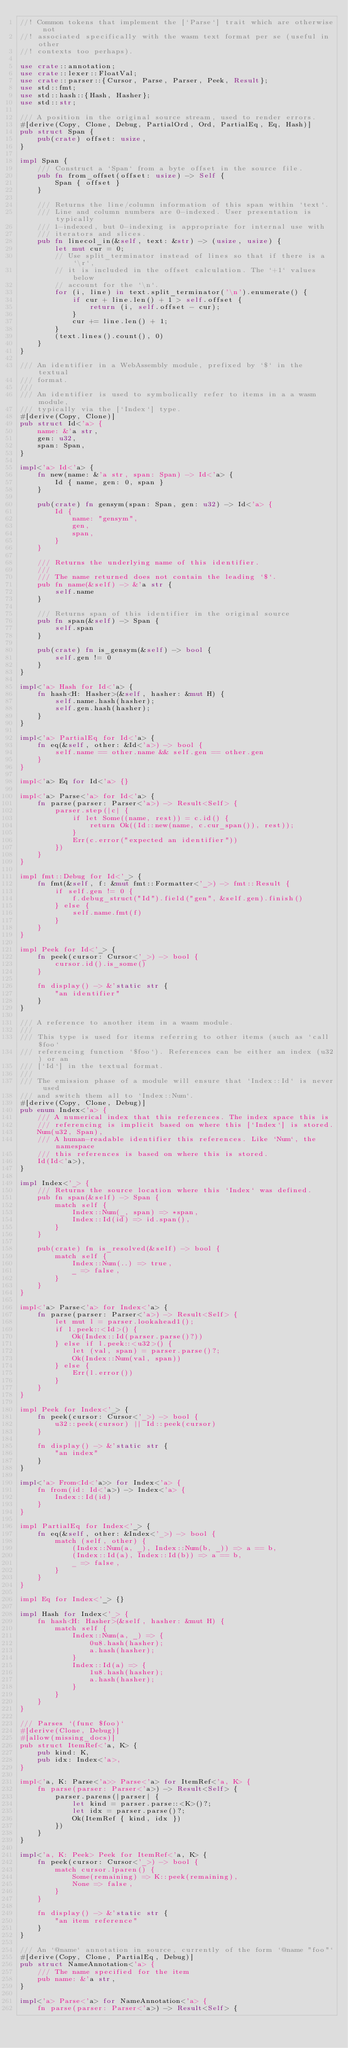<code> <loc_0><loc_0><loc_500><loc_500><_Rust_>//! Common tokens that implement the [`Parse`] trait which are otherwise not
//! associated specifically with the wasm text format per se (useful in other
//! contexts too perhaps).

use crate::annotation;
use crate::lexer::FloatVal;
use crate::parser::{Cursor, Parse, Parser, Peek, Result};
use std::fmt;
use std::hash::{Hash, Hasher};
use std::str;

/// A position in the original source stream, used to render errors.
#[derive(Copy, Clone, Debug, PartialOrd, Ord, PartialEq, Eq, Hash)]
pub struct Span {
    pub(crate) offset: usize,
}

impl Span {
    /// Construct a `Span` from a byte offset in the source file.
    pub fn from_offset(offset: usize) -> Self {
        Span { offset }
    }

    /// Returns the line/column information of this span within `text`.
    /// Line and column numbers are 0-indexed. User presentation is typically
    /// 1-indexed, but 0-indexing is appropriate for internal use with
    /// iterators and slices.
    pub fn linecol_in(&self, text: &str) -> (usize, usize) {
        let mut cur = 0;
        // Use split_terminator instead of lines so that if there is a `\r`,
        // it is included in the offset calculation. The `+1` values below
        // account for the `\n`.
        for (i, line) in text.split_terminator('\n').enumerate() {
            if cur + line.len() + 1 > self.offset {
                return (i, self.offset - cur);
            }
            cur += line.len() + 1;
        }
        (text.lines().count(), 0)
    }
}

/// An identifier in a WebAssembly module, prefixed by `$` in the textual
/// format.
///
/// An identifier is used to symbolically refer to items in a a wasm module,
/// typically via the [`Index`] type.
#[derive(Copy, Clone)]
pub struct Id<'a> {
    name: &'a str,
    gen: u32,
    span: Span,
}

impl<'a> Id<'a> {
    fn new(name: &'a str, span: Span) -> Id<'a> {
        Id { name, gen: 0, span }
    }

    pub(crate) fn gensym(span: Span, gen: u32) -> Id<'a> {
        Id {
            name: "gensym",
            gen,
            span,
        }
    }

    /// Returns the underlying name of this identifier.
    ///
    /// The name returned does not contain the leading `$`.
    pub fn name(&self) -> &'a str {
        self.name
    }

    /// Returns span of this identifier in the original source
    pub fn span(&self) -> Span {
        self.span
    }

    pub(crate) fn is_gensym(&self) -> bool {
        self.gen != 0
    }
}

impl<'a> Hash for Id<'a> {
    fn hash<H: Hasher>(&self, hasher: &mut H) {
        self.name.hash(hasher);
        self.gen.hash(hasher);
    }
}

impl<'a> PartialEq for Id<'a> {
    fn eq(&self, other: &Id<'a>) -> bool {
        self.name == other.name && self.gen == other.gen
    }
}

impl<'a> Eq for Id<'a> {}

impl<'a> Parse<'a> for Id<'a> {
    fn parse(parser: Parser<'a>) -> Result<Self> {
        parser.step(|c| {
            if let Some((name, rest)) = c.id() {
                return Ok((Id::new(name, c.cur_span()), rest));
            }
            Err(c.error("expected an identifier"))
        })
    }
}

impl fmt::Debug for Id<'_> {
    fn fmt(&self, f: &mut fmt::Formatter<'_>) -> fmt::Result {
        if self.gen != 0 {
            f.debug_struct("Id").field("gen", &self.gen).finish()
        } else {
            self.name.fmt(f)
        }
    }
}

impl Peek for Id<'_> {
    fn peek(cursor: Cursor<'_>) -> bool {
        cursor.id().is_some()
    }

    fn display() -> &'static str {
        "an identifier"
    }
}

/// A reference to another item in a wasm module.
///
/// This type is used for items referring to other items (such as `call $foo`
/// referencing function `$foo`). References can be either an index (u32) or an
/// [`Id`] in the textual format.
///
/// The emission phase of a module will ensure that `Index::Id` is never used
/// and switch them all to `Index::Num`.
#[derive(Copy, Clone, Debug)]
pub enum Index<'a> {
    /// A numerical index that this references. The index space this is
    /// referencing is implicit based on where this [`Index`] is stored.
    Num(u32, Span),
    /// A human-readable identifier this references. Like `Num`, the namespace
    /// this references is based on where this is stored.
    Id(Id<'a>),
}

impl Index<'_> {
    /// Returns the source location where this `Index` was defined.
    pub fn span(&self) -> Span {
        match self {
            Index::Num(_, span) => *span,
            Index::Id(id) => id.span(),
        }
    }

    pub(crate) fn is_resolved(&self) -> bool {
        match self {
            Index::Num(..) => true,
            _ => false,
        }
    }
}

impl<'a> Parse<'a> for Index<'a> {
    fn parse(parser: Parser<'a>) -> Result<Self> {
        let mut l = parser.lookahead1();
        if l.peek::<Id>() {
            Ok(Index::Id(parser.parse()?))
        } else if l.peek::<u32>() {
            let (val, span) = parser.parse()?;
            Ok(Index::Num(val, span))
        } else {
            Err(l.error())
        }
    }
}

impl Peek for Index<'_> {
    fn peek(cursor: Cursor<'_>) -> bool {
        u32::peek(cursor) || Id::peek(cursor)
    }

    fn display() -> &'static str {
        "an index"
    }
}

impl<'a> From<Id<'a>> for Index<'a> {
    fn from(id: Id<'a>) -> Index<'a> {
        Index::Id(id)
    }
}

impl PartialEq for Index<'_> {
    fn eq(&self, other: &Index<'_>) -> bool {
        match (self, other) {
            (Index::Num(a, _), Index::Num(b, _)) => a == b,
            (Index::Id(a), Index::Id(b)) => a == b,
            _ => false,
        }
    }
}

impl Eq for Index<'_> {}

impl Hash for Index<'_> {
    fn hash<H: Hasher>(&self, hasher: &mut H) {
        match self {
            Index::Num(a, _) => {
                0u8.hash(hasher);
                a.hash(hasher);
            }
            Index::Id(a) => {
                1u8.hash(hasher);
                a.hash(hasher);
            }
        }
    }
}

/// Parses `(func $foo)`
#[derive(Clone, Debug)]
#[allow(missing_docs)]
pub struct ItemRef<'a, K> {
    pub kind: K,
    pub idx: Index<'a>,
}

impl<'a, K: Parse<'a>> Parse<'a> for ItemRef<'a, K> {
    fn parse(parser: Parser<'a>) -> Result<Self> {
        parser.parens(|parser| {
            let kind = parser.parse::<K>()?;
            let idx = parser.parse()?;
            Ok(ItemRef { kind, idx })
        })
    }
}

impl<'a, K: Peek> Peek for ItemRef<'a, K> {
    fn peek(cursor: Cursor<'_>) -> bool {
        match cursor.lparen() {
            Some(remaining) => K::peek(remaining),
            None => false,
        }
    }

    fn display() -> &'static str {
        "an item reference"
    }
}

/// An `@name` annotation in source, currently of the form `@name "foo"`
#[derive(Copy, Clone, PartialEq, Debug)]
pub struct NameAnnotation<'a> {
    /// The name specified for the item
    pub name: &'a str,
}

impl<'a> Parse<'a> for NameAnnotation<'a> {
    fn parse(parser: Parser<'a>) -> Result<Self> {</code> 